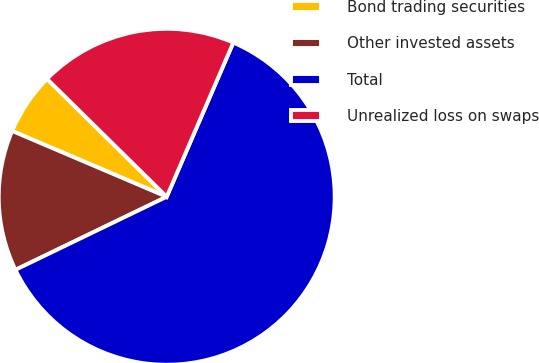Convert chart. <chart><loc_0><loc_0><loc_500><loc_500><pie_chart><fcel>Bond trading securities<fcel>Other invested assets<fcel>Total<fcel>Unrealized loss on swaps<nl><fcel>5.97%<fcel>13.57%<fcel>61.35%<fcel>19.11%<nl></chart> 